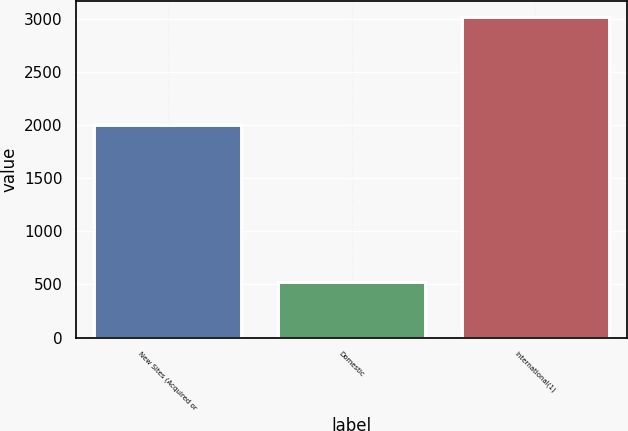Convert chart. <chart><loc_0><loc_0><loc_500><loc_500><bar_chart><fcel>New Sites (Acquired or<fcel>Domestic<fcel>International(1)<nl><fcel>2009<fcel>528<fcel>3022<nl></chart> 